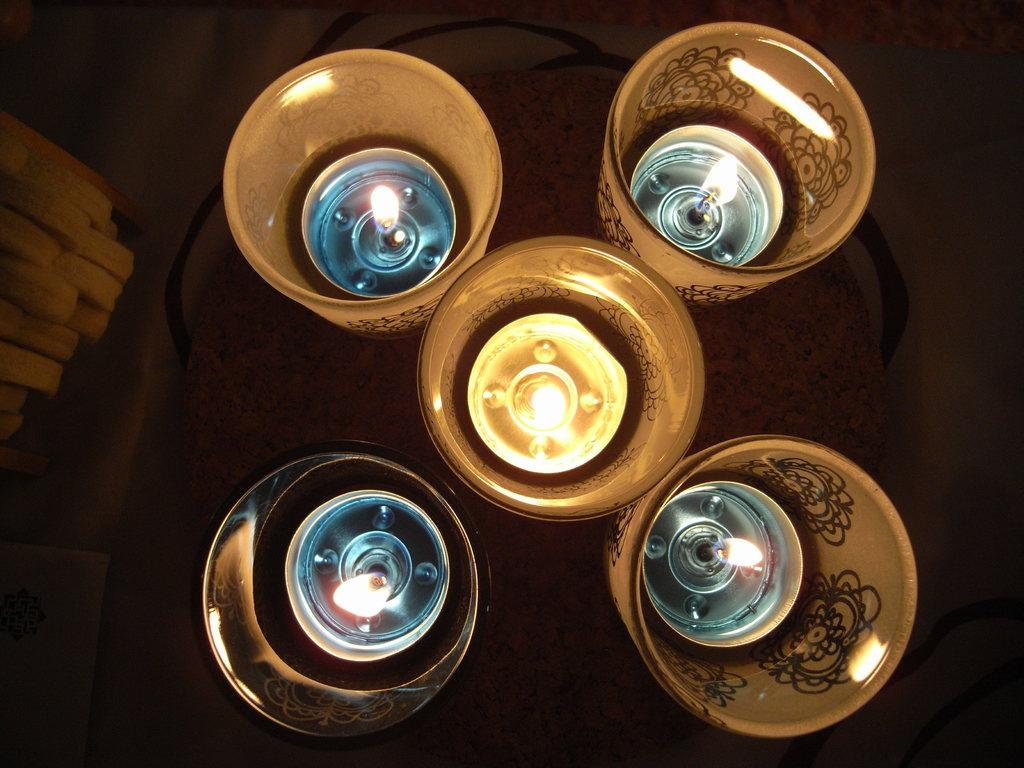What objects are on the table in the image? There are candles in glasses on a table. Can you describe any other objects present in the image? There are a few objects present in the image, but their specific details are not mentioned in the provided facts. What type of mark can be seen on the goose in the image? There is no goose present in the image, so it is not possible to determine if there is any mark on it. 